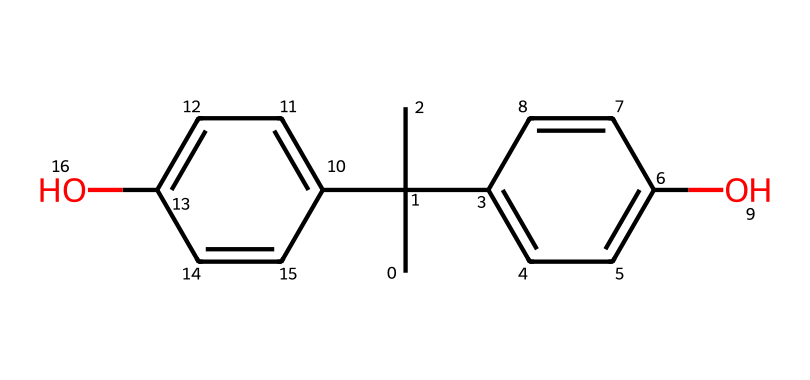What is the chemical name of the compound represented by this SMILES? The SMILES indicates that there are two phenolic groups and a tertiary carbon, suggesting it is Bisphenol A.
Answer: Bisphenol A How many hydroxyl groups are in this chemical structure? By examining the structure indicated in the SMILES, there are two – each attached to the phenolic rings.
Answer: two What is the total number of carbon atoms in the structure? Counting all carbon atoms indicated by the structure, there are 15 in total.
Answer: 15 Does this compound exhibit antioxidant properties? Yes, the presence of hydroxyl groups contributes to its antioxidant activity by scavenging free radicals.
Answer: Yes How many double bonds are present in this molecule? The structure includes 4 double bonds, evident in the aromatic rings and between specific carbon atoms.
Answer: 4 What is the primary functional group in this compound? The primary functional group present in the structure is the phenolic hydroxyl group, as indicated by the -OH.
Answer: phenolic hydroxyl group What structural feature allows this chemical to act as an antioxidant? The hydroxyl groups are responsible for the donation of hydrogen atoms to free radicals, making it an antioxidant.
Answer: hydroxyl groups 